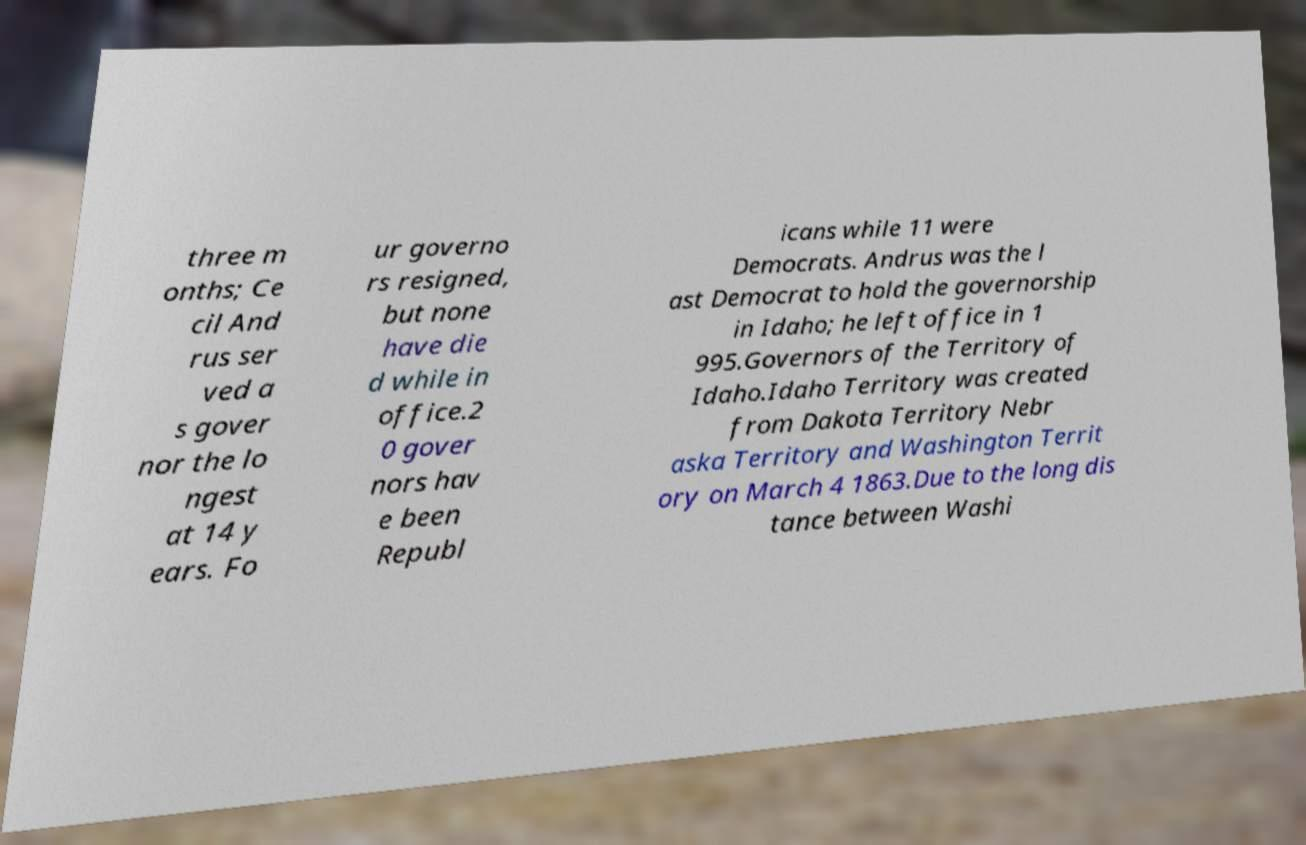For documentation purposes, I need the text within this image transcribed. Could you provide that? three m onths; Ce cil And rus ser ved a s gover nor the lo ngest at 14 y ears. Fo ur governo rs resigned, but none have die d while in office.2 0 gover nors hav e been Republ icans while 11 were Democrats. Andrus was the l ast Democrat to hold the governorship in Idaho; he left office in 1 995.Governors of the Territory of Idaho.Idaho Territory was created from Dakota Territory Nebr aska Territory and Washington Territ ory on March 4 1863.Due to the long dis tance between Washi 